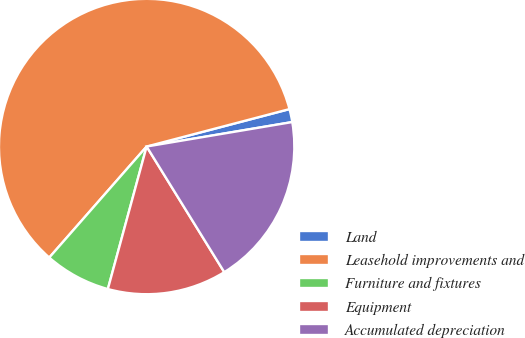Convert chart to OTSL. <chart><loc_0><loc_0><loc_500><loc_500><pie_chart><fcel>Land<fcel>Leasehold improvements and<fcel>Furniture and fixtures<fcel>Equipment<fcel>Accumulated depreciation<nl><fcel>1.43%<fcel>59.47%<fcel>7.23%<fcel>13.04%<fcel>18.84%<nl></chart> 